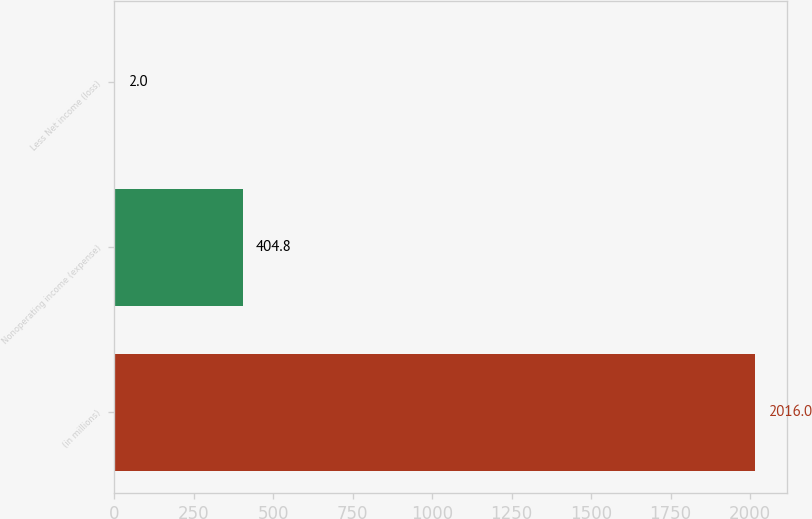Convert chart. <chart><loc_0><loc_0><loc_500><loc_500><bar_chart><fcel>(in millions)<fcel>Nonoperating income (expense)<fcel>Less Net income (loss)<nl><fcel>2016<fcel>404.8<fcel>2<nl></chart> 